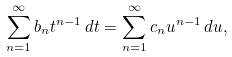<formula> <loc_0><loc_0><loc_500><loc_500>\sum ^ { \infty } _ { n = 1 } b _ { n } t ^ { n - 1 } \, d t = \sum ^ { \infty } _ { n = 1 } c _ { n } u ^ { n - 1 } \, d u ,</formula> 